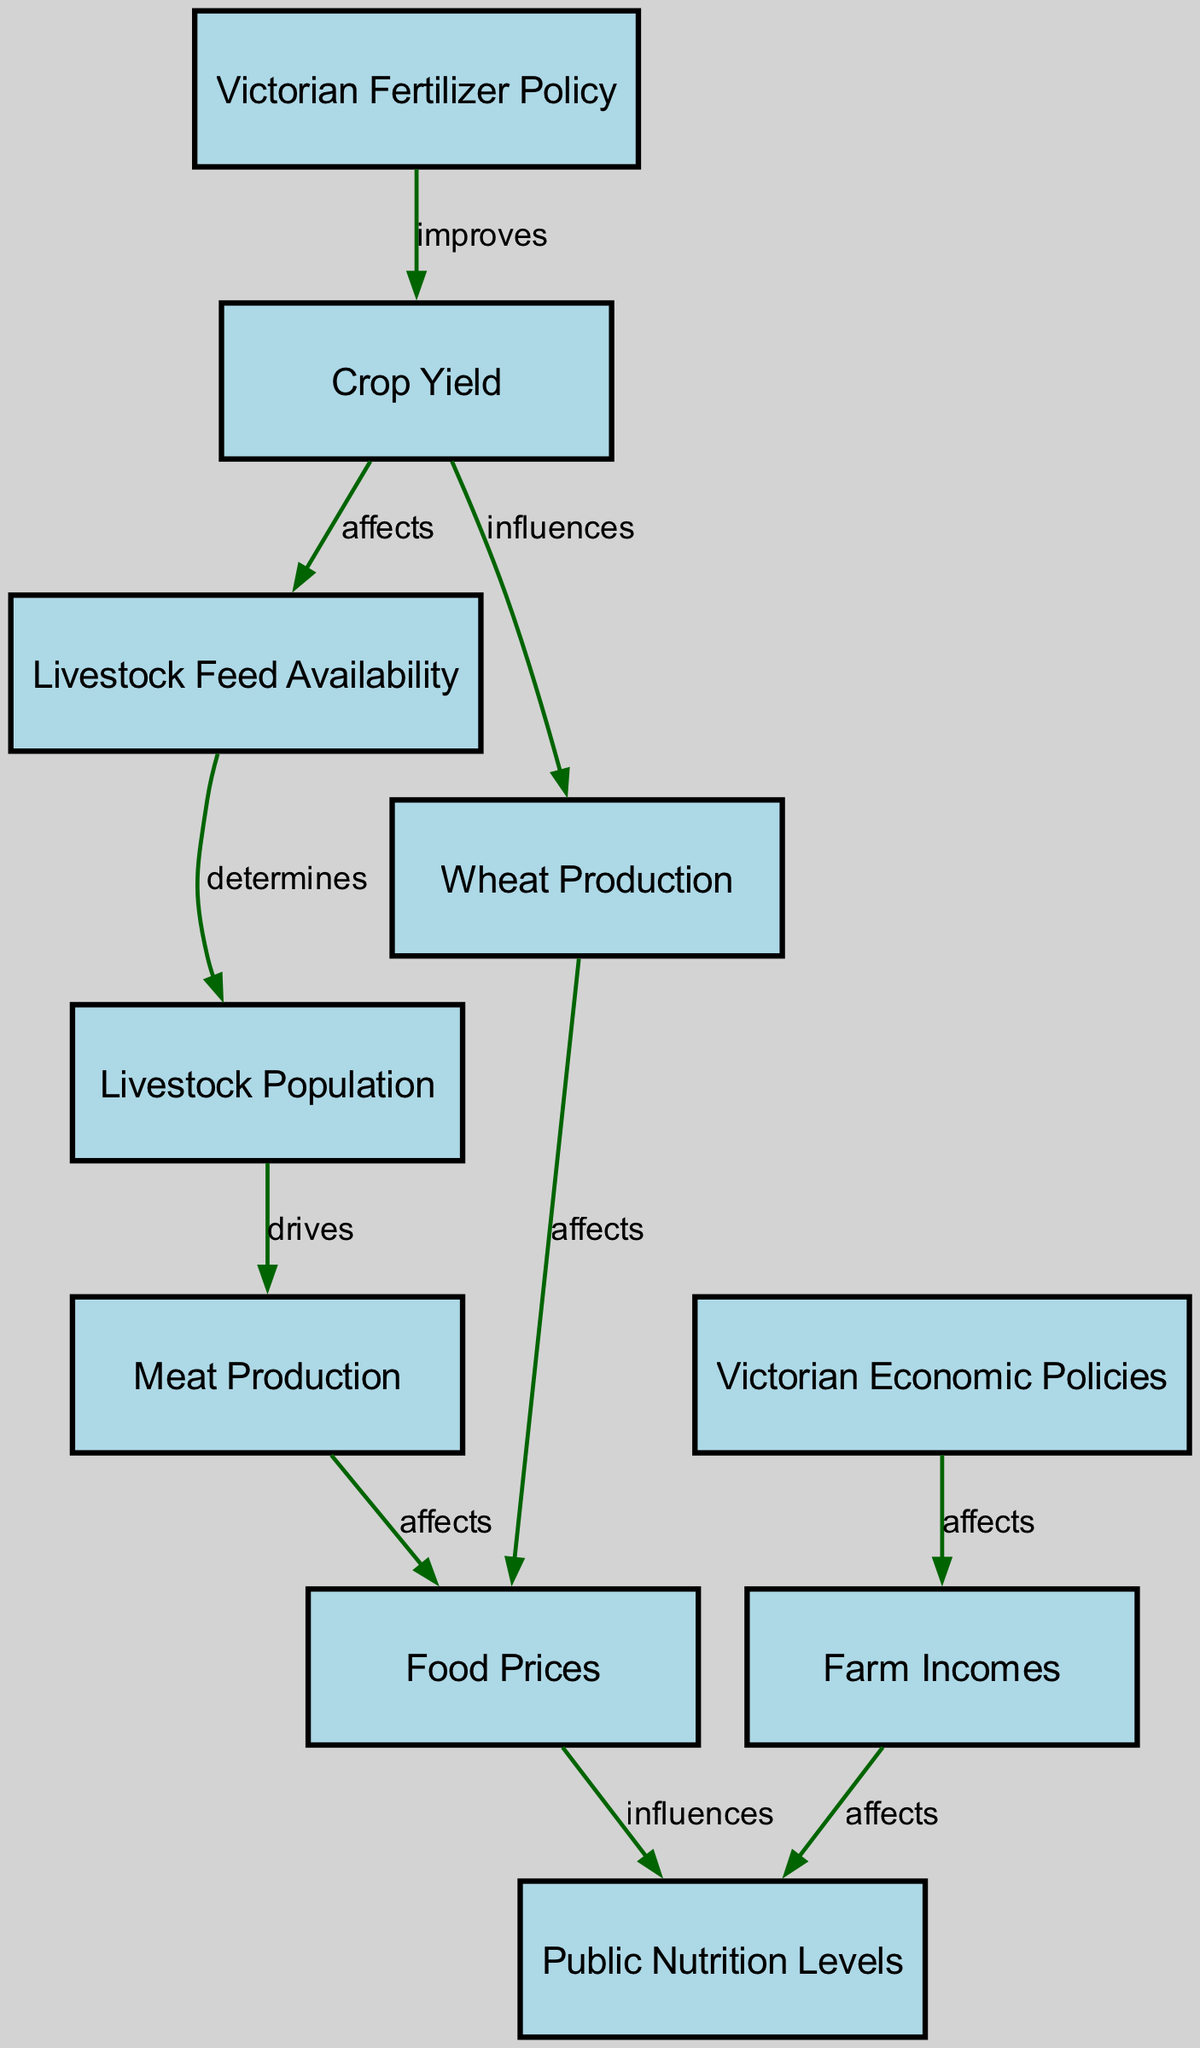What node improves crop yield? The node labeled "Victorian Fertilizer Policy" is indicated to improve crop yield in the diagram. It shows a direct relationship with an edge labeled "improves" pointing towards the "Crop Yield" node.
Answer: Victorian Fertilizer Policy How many nodes are present in the diagram? The diagram consists of a total of ten nodes, which include various aspects of the Victorian-era agriculture impact. Each node represents a distinct concept in the food chain.
Answer: 10 What influences wheat production? The diagram indicates that "Crop Yield" influences "Wheat Production," as shown by the edge labeled "influences" connecting these two nodes, demonstrating that an increase in crop yield would lead to an increase in wheat production.
Answer: Crop Yield Which two nodes affect public nutrition levels? The nodes affecting public nutrition levels are "Food Prices" and "Farm Incomes." Both nodes have edges leading to "Public Nutrition Levels," showing that they contribute to the overall nutrition levels in the society.
Answer: Food Prices, Farm Incomes What drives meat production? The diagram shows that "Livestock Population" drives "Meat Production," which is depicted by the edge labeled "drives" leading from the livestock population node to the meat production node, indicating livestock population is a key factor.
Answer: Livestock Population What are the two relationships involving crop yield? Crop yield has two significant relationships in the diagram: it improves when influenced by the "Victorian Fertilizer Policy" and also affects both "Wheat Production" and "Livestock Feed Availability," changing how other elements are influenced within the food chain.
Answer: Improves, Affects How does livestock feed availability affect livestock population? The diagram illustrates that "Livestock Feed Availability" determines the "Livestock Population." This means that the availability of livestock feed directly influences the size of the livestock population, depicted by the edge labeled "determines."
Answer: Determines What is affected by wheat production? "Food Prices" is affected by "Wheat Production," as shown in the diagram where there is an edge connecting the two nodes with the label "affects," indicating that changes in wheat production will influence food prices.
Answer: Food Prices What relationship do economic policies have with farm incomes? The economic policies affect farm incomes, as a direct edge labeled "affects" connects the node "Victorian Economic Policies" to "Farm Incomes," indicating that the policies implemented during this era have an impact on the financial well-being of farms.
Answer: Affects 